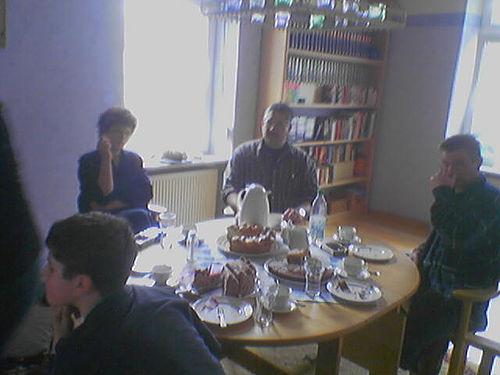Is the meal over?
Short answer required. Yes. What time of day are they eating?
Give a very brief answer. Afternoon. Are there gift baskets in this photo?
Answer briefly. No. What is on the shelves?
Be succinct. Books. Is there any food on the table?
Quick response, please. Yes. 